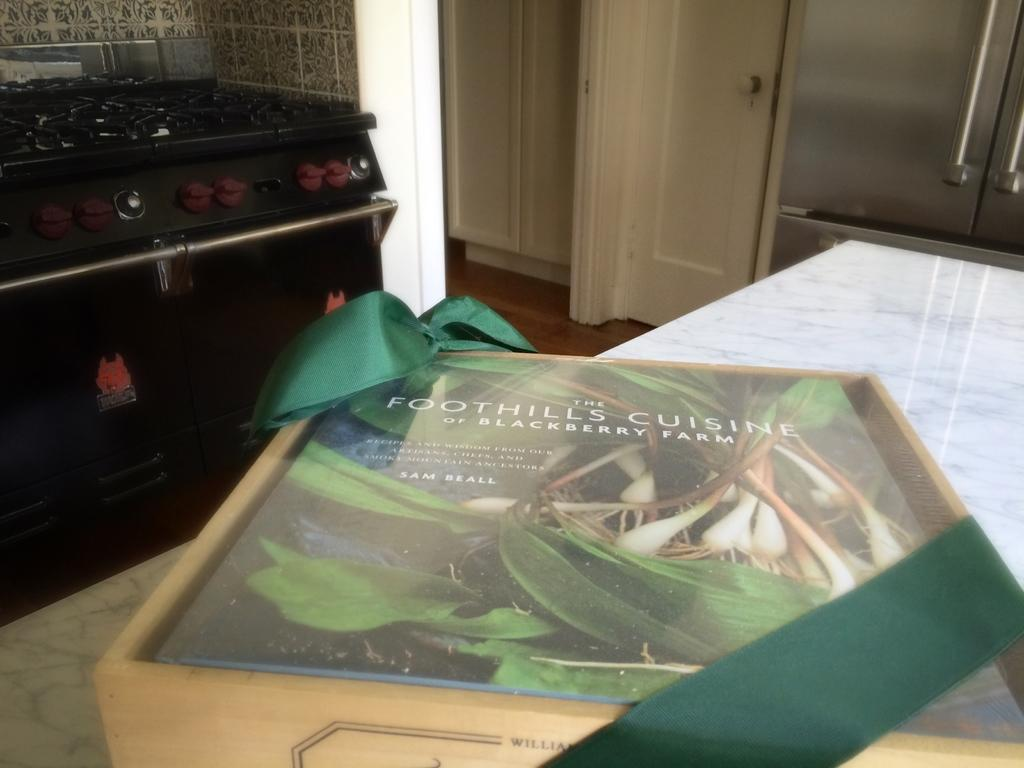<image>
Summarize the visual content of the image. A cookbook of recipes from Blackberry Farm sits in a wooden box with a green ribbon. 